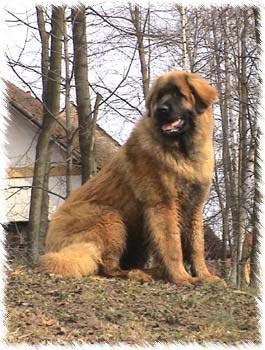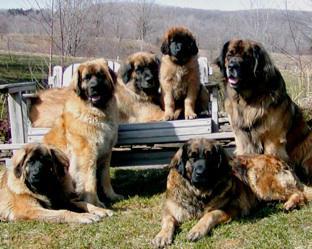The first image is the image on the left, the second image is the image on the right. For the images displayed, is the sentence "There are at least three fluffy black and tan dogs." factually correct? Answer yes or no. Yes. The first image is the image on the left, the second image is the image on the right. Analyze the images presented: Is the assertion "We've got two dogs here." valid? Answer yes or no. No. 